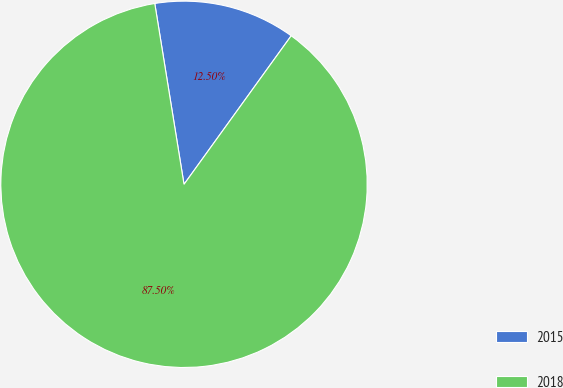Convert chart to OTSL. <chart><loc_0><loc_0><loc_500><loc_500><pie_chart><fcel>2015<fcel>2018<nl><fcel>12.5%<fcel>87.5%<nl></chart> 